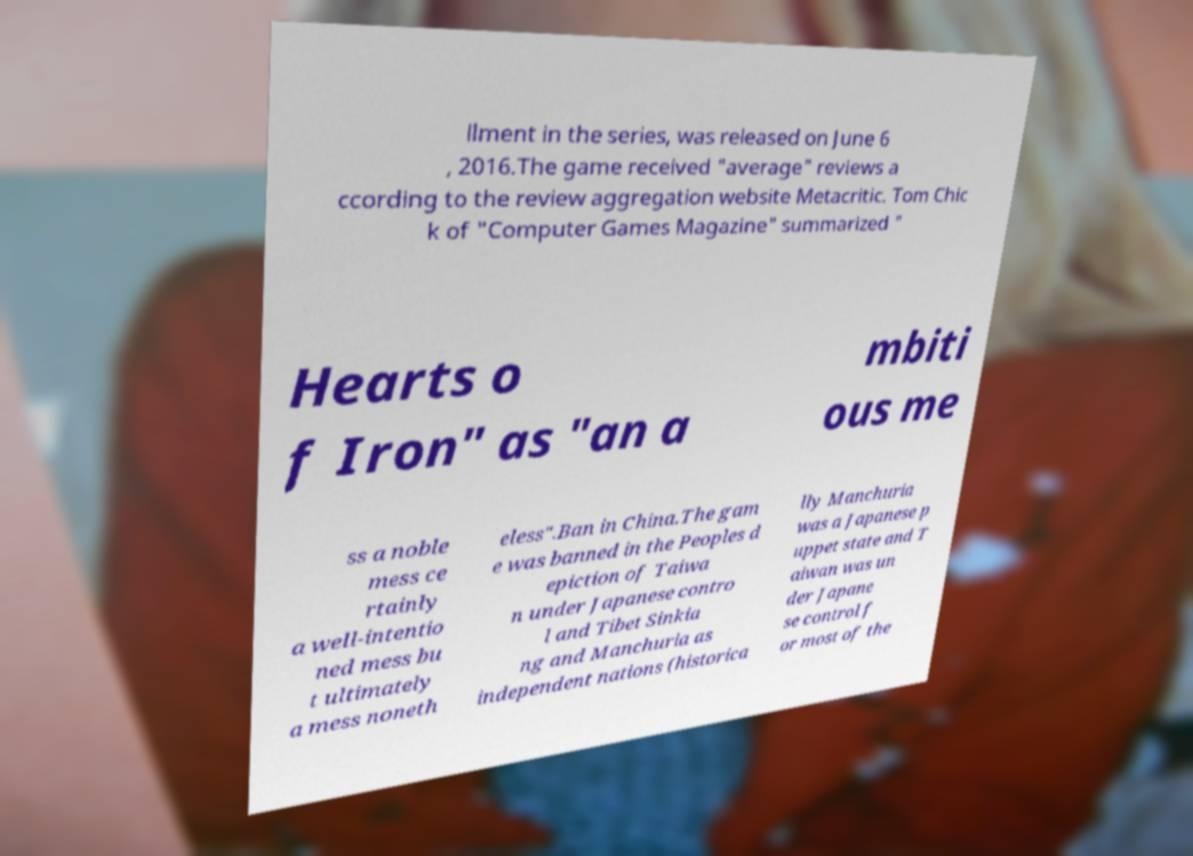Could you extract and type out the text from this image? llment in the series, was released on June 6 , 2016.The game received "average" reviews a ccording to the review aggregation website Metacritic. Tom Chic k of "Computer Games Magazine" summarized " Hearts o f Iron" as "an a mbiti ous me ss a noble mess ce rtainly a well-intentio ned mess bu t ultimately a mess noneth eless".Ban in China.The gam e was banned in the Peoples d epiction of Taiwa n under Japanese contro l and Tibet Sinkia ng and Manchuria as independent nations (historica lly Manchuria was a Japanese p uppet state and T aiwan was un der Japane se control f or most of the 